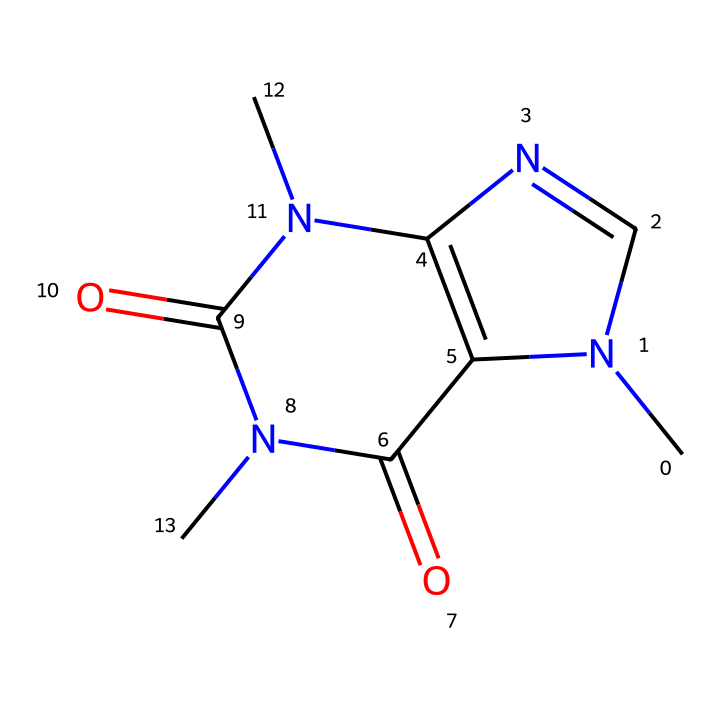What is the molecular formula of caffeine? To determine the molecular formula, we analyze the SMILES representation. Counting the atoms represented, we find 8 carbon atoms (C), 10 hydrogen atoms (H), 4 nitrogen atoms (N), and 2 oxygen atoms (O). Therefore, the chemical formula is C8H10N4O2.
Answer: C8H10N4O2 How many nitrogen atoms are present in caffeine? By examining the SMILES representation, we identify 4 nitrogen atoms indicated by 'N'. Each 'N' in the structure represents a nitrogen atom in the molecular composition.
Answer: 4 What type of compound is caffeine classified as? Caffeine is a stimulant and is classified as an alkaloid, which is a type of nitrogen-containing compound typically found in plants. The presence of nitrogen atoms and its overall structure supports its classification as an alkaloid.
Answer: alkaloid Does caffeine contain any functional groups? Yes, caffeine contains amine and carbonyl functional groups. The nitrogen atoms suggest amine groups, while the carbonyls (C=O bonds) are evident in the structure as well. These contribute to its chemical behavior.
Answer: yes What is the arrangement of the carbon atoms in caffeine? The SMILES representation shows that carbon atoms form a cyclic structure, which indicates a fused ring system with both pyrimidine and imidazole-like characteristics. This unique arrangement aids in the compound's stability and function.
Answer: cyclic What is the primary effect of caffeine on the human body? The primary effect of caffeine is to act as a central nervous system stimulant, which temporarily increases alertness and reduces fatigue. This effect is largely due to its molecular structure and interaction with neurotransmitter receptors.
Answer: stimulant 